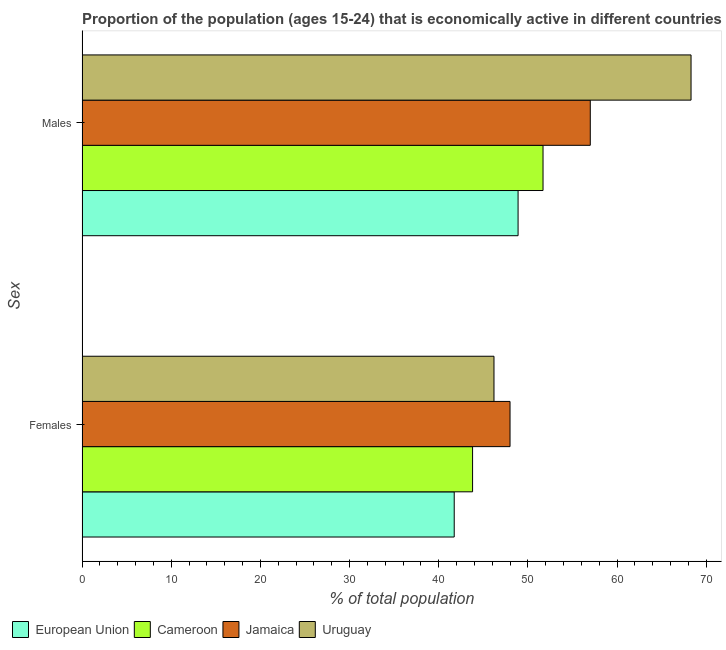How many groups of bars are there?
Give a very brief answer. 2. Are the number of bars per tick equal to the number of legend labels?
Give a very brief answer. Yes. Are the number of bars on each tick of the Y-axis equal?
Make the answer very short. Yes. How many bars are there on the 2nd tick from the bottom?
Give a very brief answer. 4. What is the label of the 2nd group of bars from the top?
Offer a very short reply. Females. What is the percentage of economically active male population in Jamaica?
Give a very brief answer. 57. Across all countries, what is the maximum percentage of economically active male population?
Ensure brevity in your answer.  68.3. Across all countries, what is the minimum percentage of economically active female population?
Ensure brevity in your answer.  41.74. In which country was the percentage of economically active female population maximum?
Make the answer very short. Jamaica. In which country was the percentage of economically active male population minimum?
Your response must be concise. European Union. What is the total percentage of economically active male population in the graph?
Provide a short and direct response. 225.9. What is the difference between the percentage of economically active female population in European Union and that in Cameroon?
Give a very brief answer. -2.06. What is the difference between the percentage of economically active male population in European Union and the percentage of economically active female population in Jamaica?
Offer a terse response. 0.9. What is the average percentage of economically active male population per country?
Give a very brief answer. 56.48. What is the difference between the percentage of economically active male population and percentage of economically active female population in European Union?
Keep it short and to the point. 7.16. In how many countries, is the percentage of economically active female population greater than 6 %?
Ensure brevity in your answer.  4. What is the ratio of the percentage of economically active female population in Cameroon to that in Uruguay?
Provide a short and direct response. 0.95. Is the percentage of economically active male population in Jamaica less than that in European Union?
Your answer should be compact. No. In how many countries, is the percentage of economically active female population greater than the average percentage of economically active female population taken over all countries?
Provide a short and direct response. 2. What does the 2nd bar from the top in Males represents?
Provide a short and direct response. Jamaica. How many bars are there?
Provide a succinct answer. 8. Are the values on the major ticks of X-axis written in scientific E-notation?
Give a very brief answer. No. Does the graph contain grids?
Ensure brevity in your answer.  No. Where does the legend appear in the graph?
Your answer should be compact. Bottom left. How many legend labels are there?
Provide a succinct answer. 4. What is the title of the graph?
Provide a succinct answer. Proportion of the population (ages 15-24) that is economically active in different countries. What is the label or title of the X-axis?
Provide a short and direct response. % of total population. What is the label or title of the Y-axis?
Your response must be concise. Sex. What is the % of total population of European Union in Females?
Your answer should be compact. 41.74. What is the % of total population of Cameroon in Females?
Your answer should be very brief. 43.8. What is the % of total population of Jamaica in Females?
Ensure brevity in your answer.  48. What is the % of total population of Uruguay in Females?
Provide a short and direct response. 46.2. What is the % of total population of European Union in Males?
Your answer should be very brief. 48.9. What is the % of total population of Cameroon in Males?
Provide a short and direct response. 51.7. What is the % of total population in Jamaica in Males?
Make the answer very short. 57. What is the % of total population of Uruguay in Males?
Ensure brevity in your answer.  68.3. Across all Sex, what is the maximum % of total population of European Union?
Give a very brief answer. 48.9. Across all Sex, what is the maximum % of total population in Cameroon?
Keep it short and to the point. 51.7. Across all Sex, what is the maximum % of total population of Uruguay?
Your response must be concise. 68.3. Across all Sex, what is the minimum % of total population in European Union?
Your answer should be compact. 41.74. Across all Sex, what is the minimum % of total population in Cameroon?
Give a very brief answer. 43.8. Across all Sex, what is the minimum % of total population of Uruguay?
Give a very brief answer. 46.2. What is the total % of total population of European Union in the graph?
Provide a short and direct response. 90.64. What is the total % of total population of Cameroon in the graph?
Your response must be concise. 95.5. What is the total % of total population in Jamaica in the graph?
Ensure brevity in your answer.  105. What is the total % of total population of Uruguay in the graph?
Provide a short and direct response. 114.5. What is the difference between the % of total population of European Union in Females and that in Males?
Give a very brief answer. -7.16. What is the difference between the % of total population of Uruguay in Females and that in Males?
Your response must be concise. -22.1. What is the difference between the % of total population of European Union in Females and the % of total population of Cameroon in Males?
Your response must be concise. -9.96. What is the difference between the % of total population of European Union in Females and the % of total population of Jamaica in Males?
Offer a very short reply. -15.26. What is the difference between the % of total population in European Union in Females and the % of total population in Uruguay in Males?
Keep it short and to the point. -26.56. What is the difference between the % of total population in Cameroon in Females and the % of total population in Jamaica in Males?
Provide a short and direct response. -13.2. What is the difference between the % of total population in Cameroon in Females and the % of total population in Uruguay in Males?
Your answer should be very brief. -24.5. What is the difference between the % of total population in Jamaica in Females and the % of total population in Uruguay in Males?
Keep it short and to the point. -20.3. What is the average % of total population in European Union per Sex?
Give a very brief answer. 45.32. What is the average % of total population of Cameroon per Sex?
Offer a very short reply. 47.75. What is the average % of total population of Jamaica per Sex?
Keep it short and to the point. 52.5. What is the average % of total population of Uruguay per Sex?
Your answer should be compact. 57.25. What is the difference between the % of total population in European Union and % of total population in Cameroon in Females?
Your response must be concise. -2.06. What is the difference between the % of total population of European Union and % of total population of Jamaica in Females?
Keep it short and to the point. -6.26. What is the difference between the % of total population of European Union and % of total population of Uruguay in Females?
Your answer should be very brief. -4.46. What is the difference between the % of total population of Cameroon and % of total population of Jamaica in Females?
Make the answer very short. -4.2. What is the difference between the % of total population of Cameroon and % of total population of Uruguay in Females?
Offer a terse response. -2.4. What is the difference between the % of total population of European Union and % of total population of Cameroon in Males?
Your answer should be compact. -2.8. What is the difference between the % of total population of European Union and % of total population of Jamaica in Males?
Give a very brief answer. -8.1. What is the difference between the % of total population of European Union and % of total population of Uruguay in Males?
Your answer should be compact. -19.4. What is the difference between the % of total population of Cameroon and % of total population of Uruguay in Males?
Provide a succinct answer. -16.6. What is the ratio of the % of total population of European Union in Females to that in Males?
Your answer should be very brief. 0.85. What is the ratio of the % of total population of Cameroon in Females to that in Males?
Offer a terse response. 0.85. What is the ratio of the % of total population of Jamaica in Females to that in Males?
Your response must be concise. 0.84. What is the ratio of the % of total population in Uruguay in Females to that in Males?
Give a very brief answer. 0.68. What is the difference between the highest and the second highest % of total population in European Union?
Provide a succinct answer. 7.16. What is the difference between the highest and the second highest % of total population of Cameroon?
Your response must be concise. 7.9. What is the difference between the highest and the second highest % of total population in Uruguay?
Offer a terse response. 22.1. What is the difference between the highest and the lowest % of total population in European Union?
Give a very brief answer. 7.16. What is the difference between the highest and the lowest % of total population in Cameroon?
Your response must be concise. 7.9. What is the difference between the highest and the lowest % of total population of Jamaica?
Provide a succinct answer. 9. What is the difference between the highest and the lowest % of total population in Uruguay?
Your answer should be very brief. 22.1. 